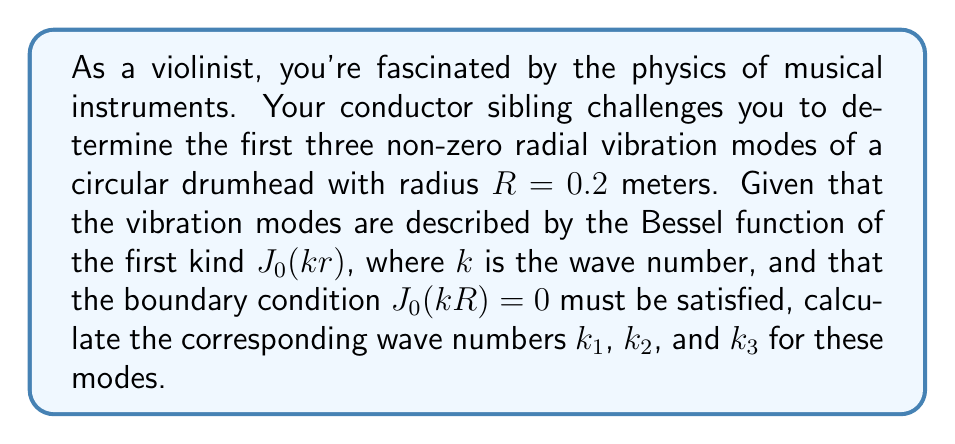Provide a solution to this math problem. To solve this problem, we'll follow these steps:

1) The vibration modes of a circular drumhead are described by the Bessel function of the first kind, $J_0(kr)$, where $r$ is the radial distance from the center and $k$ is the wave number.

2) The boundary condition for a fixed edge drumhead is that the displacement must be zero at the edge. This means:

   $J_0(kR) = 0$

3) We need to find the first three non-zero roots of this equation. These roots are well-known and tabulated. They are approximately:

   $kR = 2.4048, 5.5201, 8.6537$

4) Given that $R = 0.2$ meters, we can calculate $k$ for each mode:

   $k_1 = \frac{2.4048}{0.2} = 12.024$ m⁻¹
   
   $k_2 = \frac{5.5201}{0.2} = 27.6005$ m⁻¹
   
   $k_3 = \frac{8.6537}{0.2} = 43.2685$ m⁻¹

5) These wave numbers correspond to the first three non-zero radial vibration modes of the drumhead.

Note: The integral equation aspect of this problem is implicit in the derivation of the Bessel function solution, which involves solving the wave equation in polar coordinates using separation of variables and then applying the appropriate boundary conditions.
Answer: $k_1 = 12.024$ m⁻¹, $k_2 = 27.6005$ m⁻¹, $k_3 = 43.2685$ m⁻¹ 